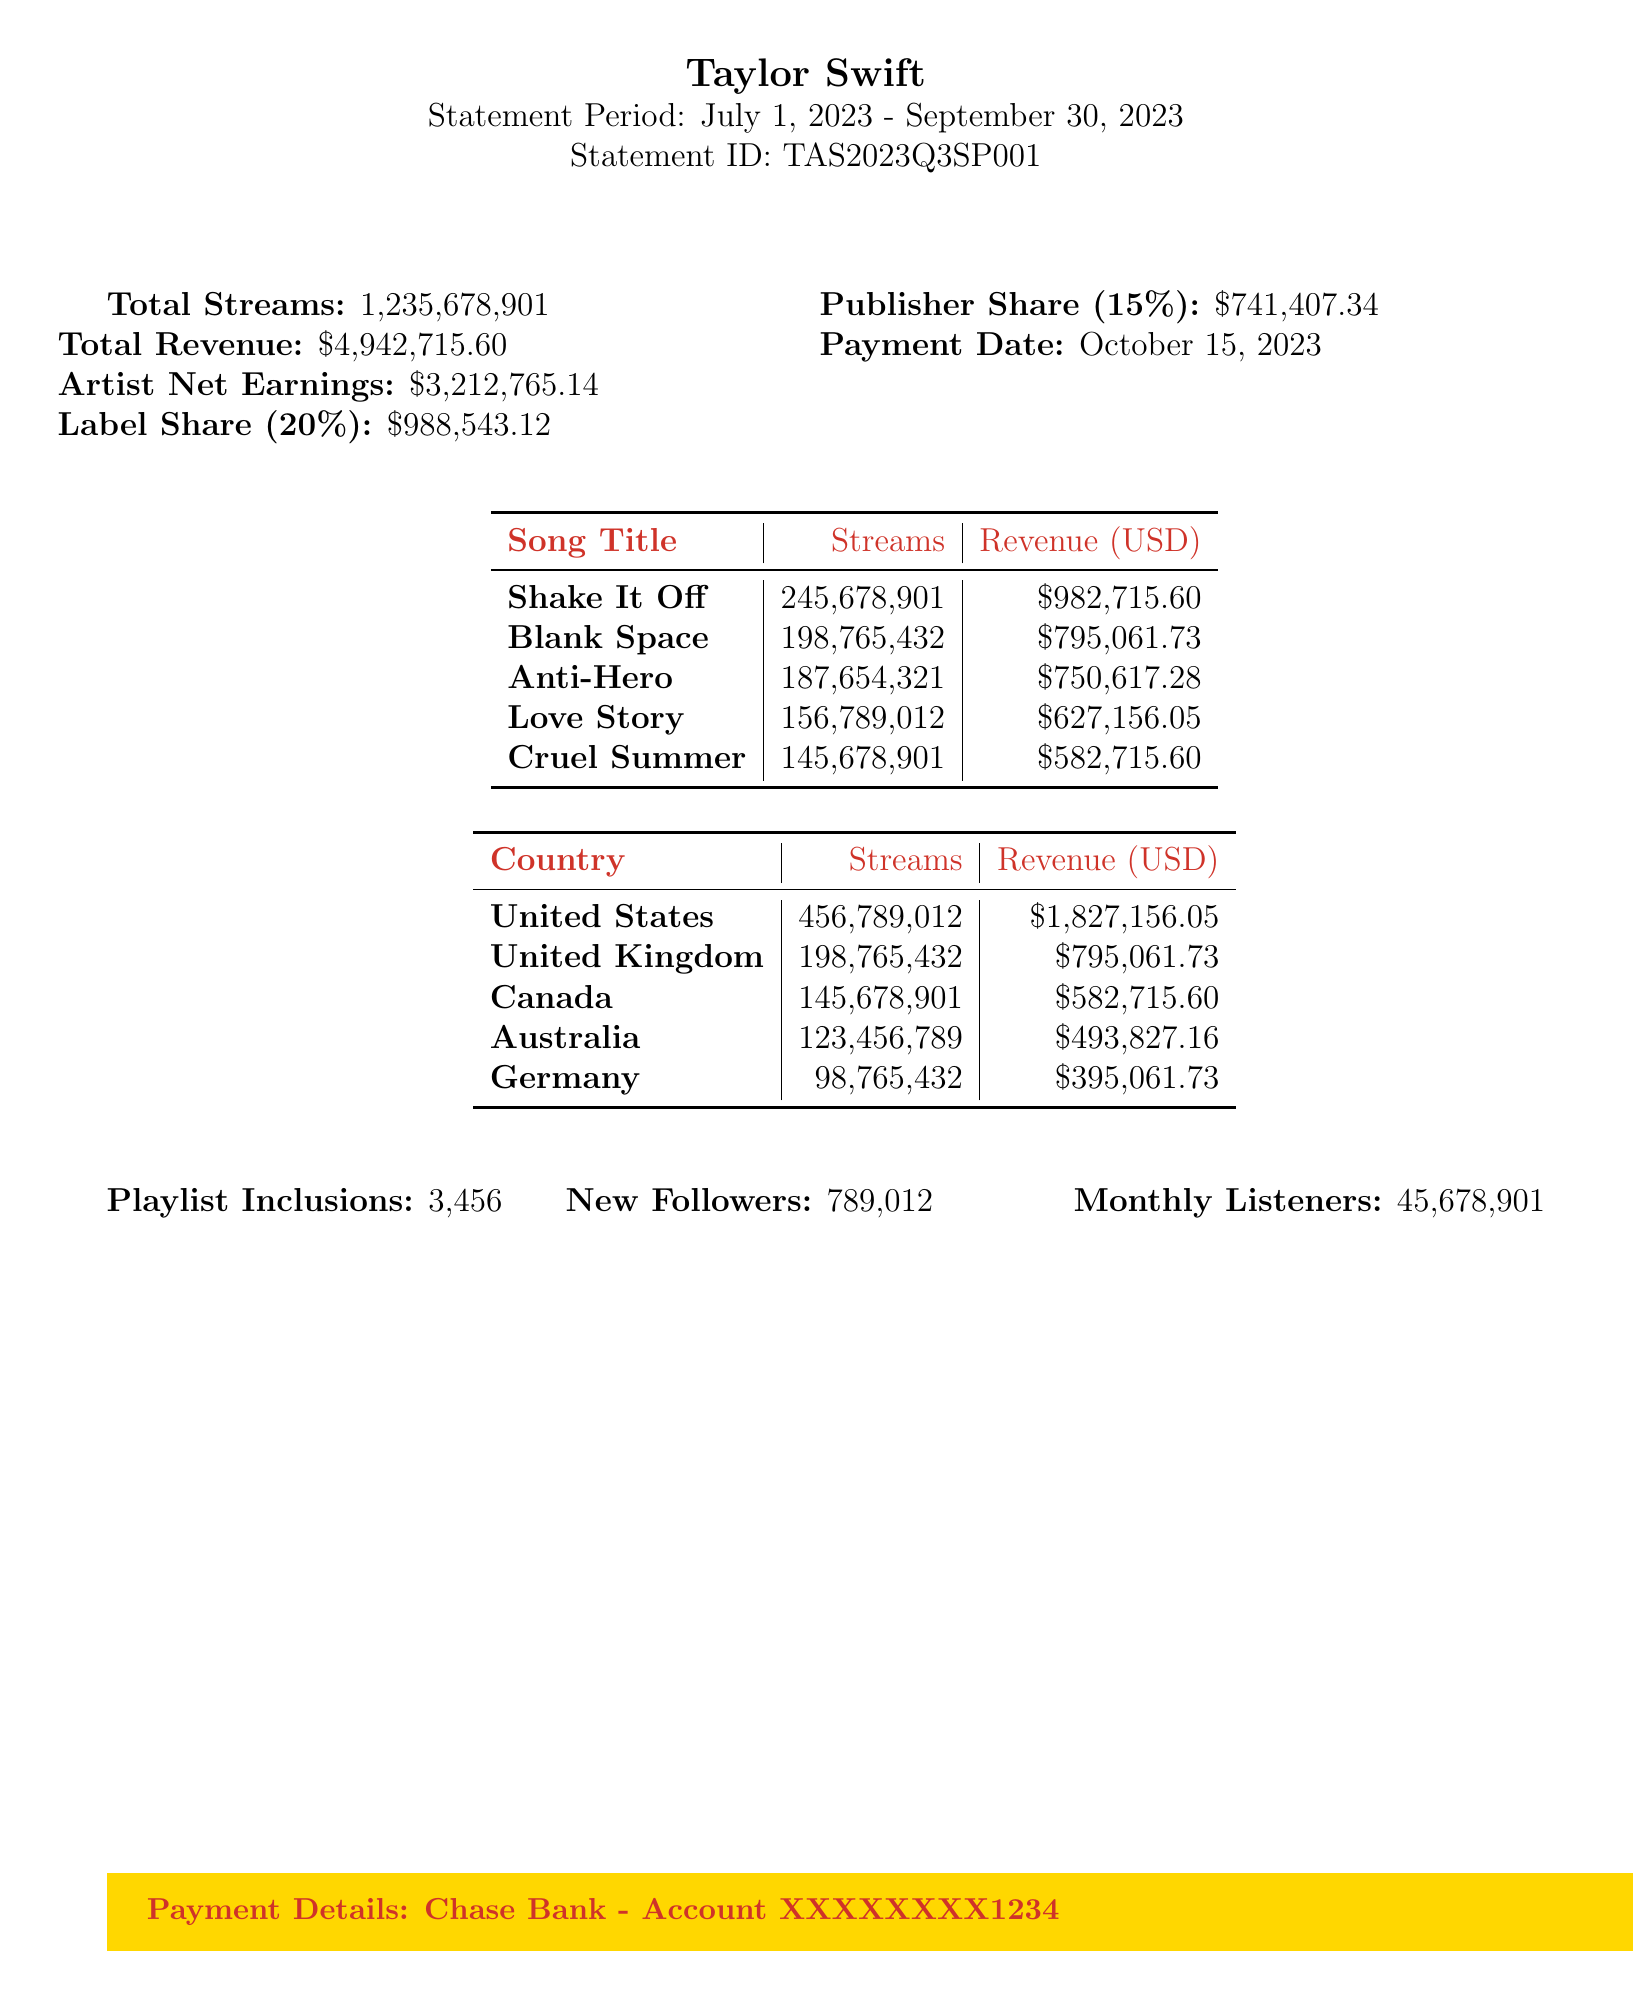what is the statement period? The statement period indicates the timeframe for the royalty calculation, which is from July 1, 2023, to September 30, 2023.
Answer: July 1, 2023 - September 30, 2023 how much is the total revenue? The total revenue is explicitly stated as the overall earnings from streaming during the statement period.
Answer: $4,942,715.60 what is the title of the song with the highest earnings? The song with the highest earnings is identified in the list of songs based on the revenue generated.
Answer: Shake It Off how many streams did "Anti-Hero" receive? The number of streams for "Anti-Hero" is specified in the earnings breakdown of the document.
Answer: 187,654,321 what is the label share percentage? The document indicates the share percentage that goes to the label based on the total earnings.
Answer: 20% which country generated the least revenue? By analyzing the revenue by country, we can determine which generated the lowest amount from streams.
Answer: Germany what is the total number of playlist inclusions? This number is provided in the additional information section of the document, reflecting the promotional exposure.
Answer: 3,456 how much are the artist's net earnings? The net earnings for the artist can be found in the summary of the financial information in the document.
Answer: $3,212,765.14 when is the payment date? The payment date details are listed in the payment information section of the statement.
Answer: October 15, 2023 